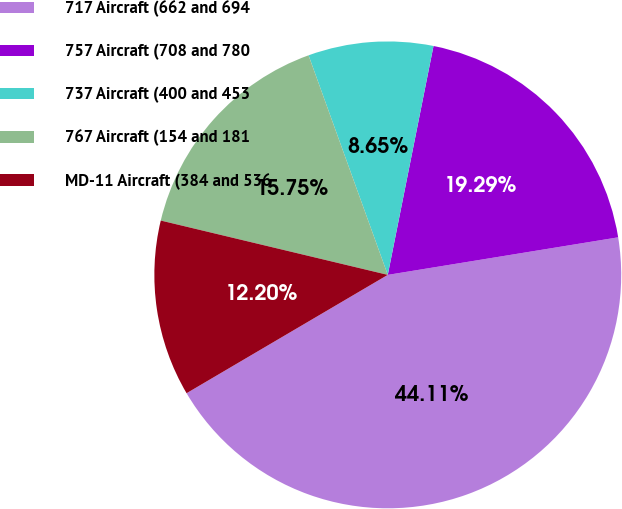Convert chart. <chart><loc_0><loc_0><loc_500><loc_500><pie_chart><fcel>717 Aircraft (662 and 694<fcel>757 Aircraft (708 and 780<fcel>737 Aircraft (400 and 453<fcel>767 Aircraft (154 and 181<fcel>MD-11 Aircraft (384 and 536<nl><fcel>44.11%<fcel>19.29%<fcel>8.65%<fcel>15.75%<fcel>12.2%<nl></chart> 